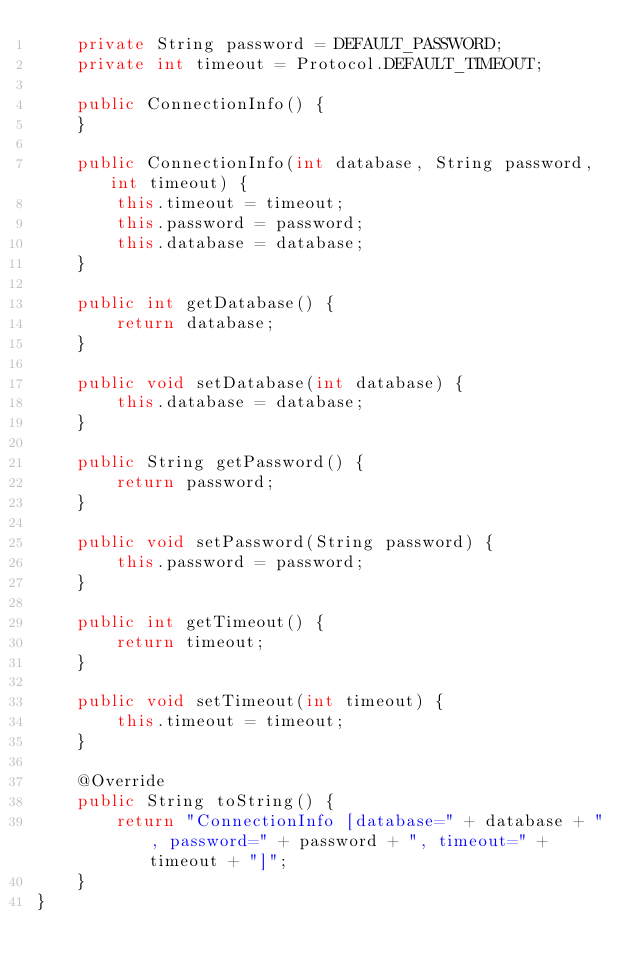Convert code to text. <code><loc_0><loc_0><loc_500><loc_500><_Java_>	private String password = DEFAULT_PASSWORD;
	private int timeout = Protocol.DEFAULT_TIMEOUT;

	public ConnectionInfo() {
	}

	public ConnectionInfo(int database, String password, int timeout) {
		this.timeout = timeout;
		this.password = password;
		this.database = database;
	}

	public int getDatabase() {
		return database;
	}

	public void setDatabase(int database) {
		this.database = database;
	}

	public String getPassword() {
		return password;
	}

	public void setPassword(String password) {
		this.password = password;
	}

	public int getTimeout() {
		return timeout;
	}

	public void setTimeout(int timeout) {
		this.timeout = timeout;
	}

	@Override
	public String toString() {
		return "ConnectionInfo [database=" + database + ", password=" + password + ", timeout=" + timeout + "]";
	}
}
</code> 